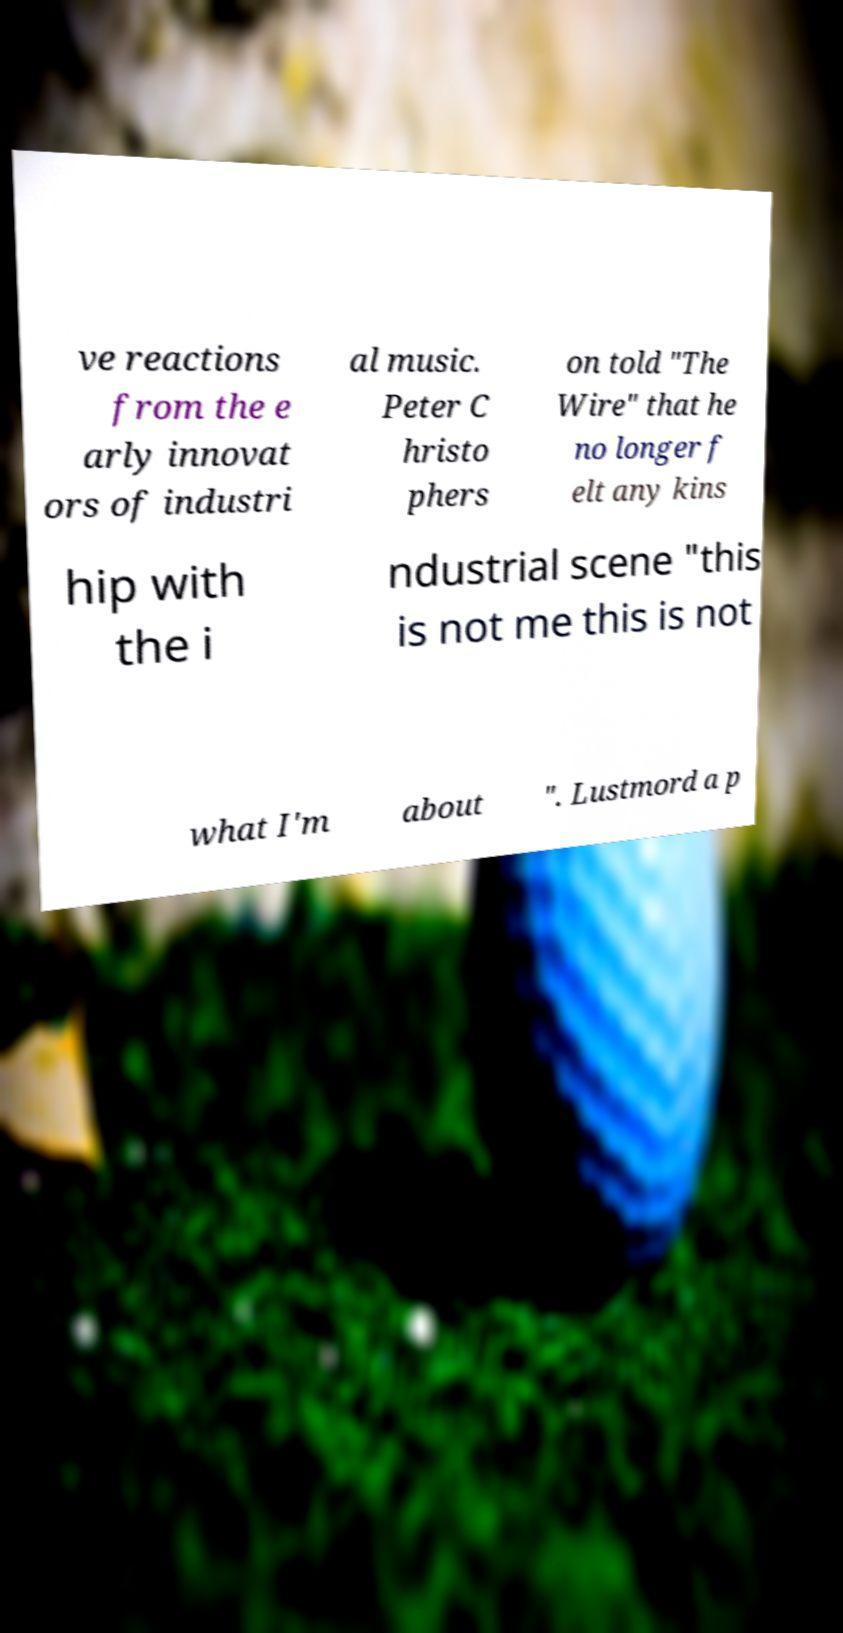What messages or text are displayed in this image? I need them in a readable, typed format. ve reactions from the e arly innovat ors of industri al music. Peter C hristo phers on told "The Wire" that he no longer f elt any kins hip with the i ndustrial scene "this is not me this is not what I'm about ". Lustmord a p 